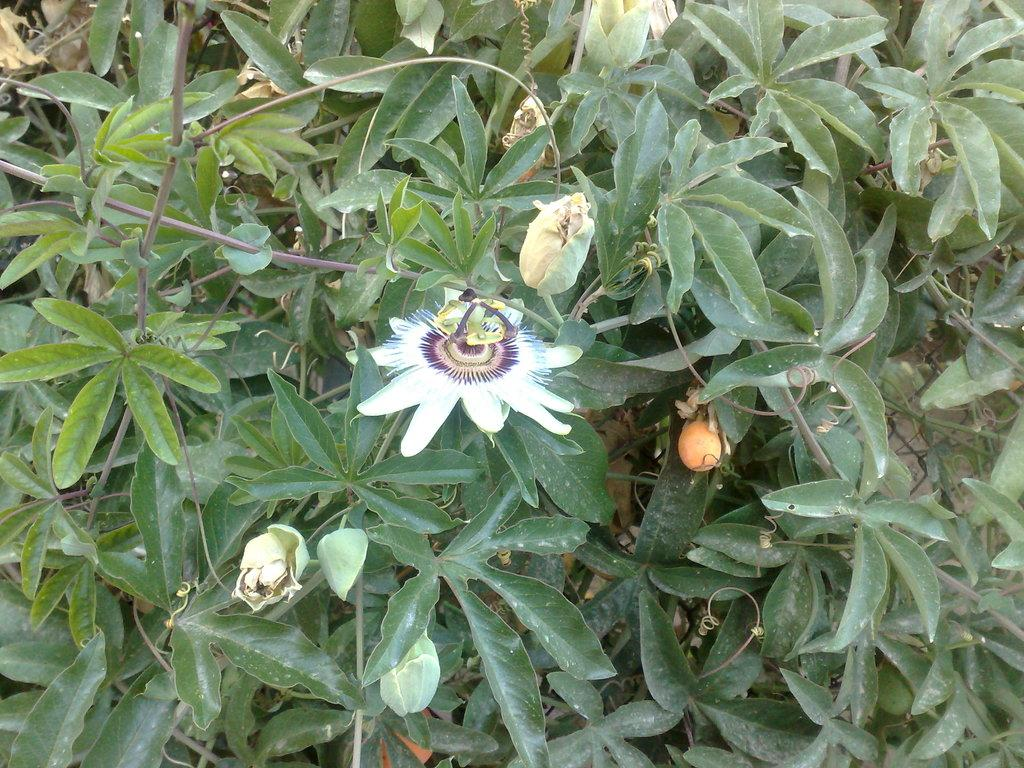What type of plant is visible in the image? There is a flower in the image. What stage of growth can be seen on the plant? There are buds in the image. What else is present on the plant besides the flower and buds? There are leaves of the plant in the image. What scientific experiment is being conducted with the flower in the image? There is no indication of a scientific experiment being conducted in the image; it simply shows a flower, buds, and leaves. 